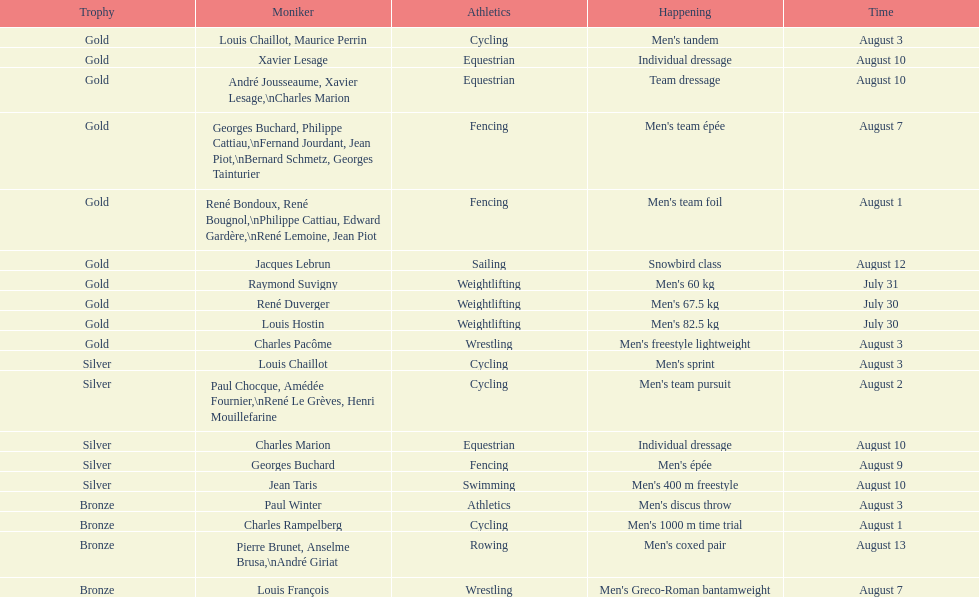How many total gold medals were won by weightlifting? 3. 